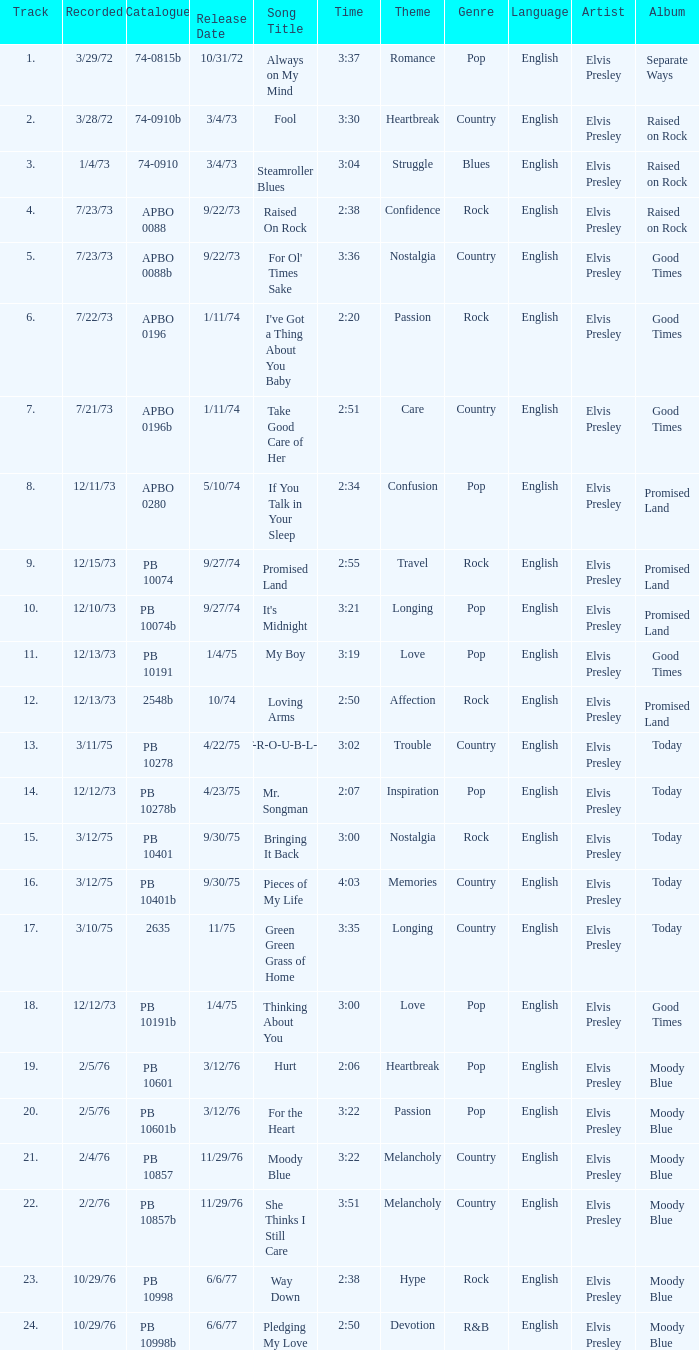Tell me the release date record on 10/29/76 and a time on 2:50 6/6/77. 